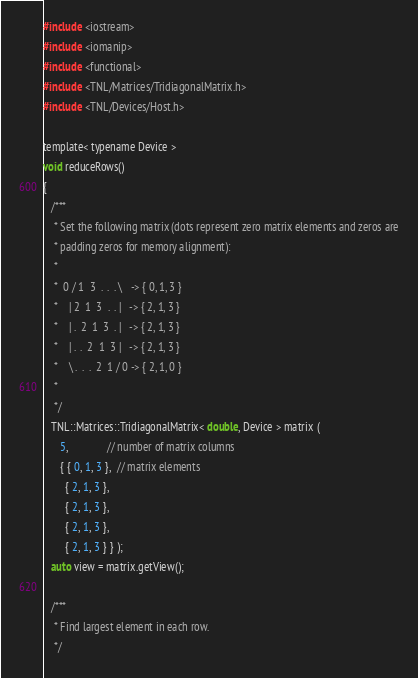<code> <loc_0><loc_0><loc_500><loc_500><_Cuda_>#include <iostream>
#include <iomanip>
#include <functional>
#include <TNL/Matrices/TridiagonalMatrix.h>
#include <TNL/Devices/Host.h>

template< typename Device >
void reduceRows()
{
   /***
    * Set the following matrix (dots represent zero matrix elements and zeros are
    * padding zeros for memory alignment):
    *
    *  0 / 1  3  .  .  . \   -> { 0, 1, 3 }
    *    | 2  1  3  .  . |   -> { 2, 1, 3 }
    *    | .  2  1  3  . |   -> { 2, 1, 3 }
    *    | .  .  2  1  3 |   -> { 2, 1, 3 }
    *    \ .  .  .  2  1 / 0 -> { 2, 1, 0 }
    *
    */
   TNL::Matrices::TridiagonalMatrix< double, Device > matrix (
      5,              // number of matrix columns
      { { 0, 1, 3 },  // matrix elements
        { 2, 1, 3 },
        { 2, 1, 3 },
        { 2, 1, 3 },
        { 2, 1, 3 } } );
   auto view = matrix.getView();

   /***
    * Find largest element in each row.
    */</code> 